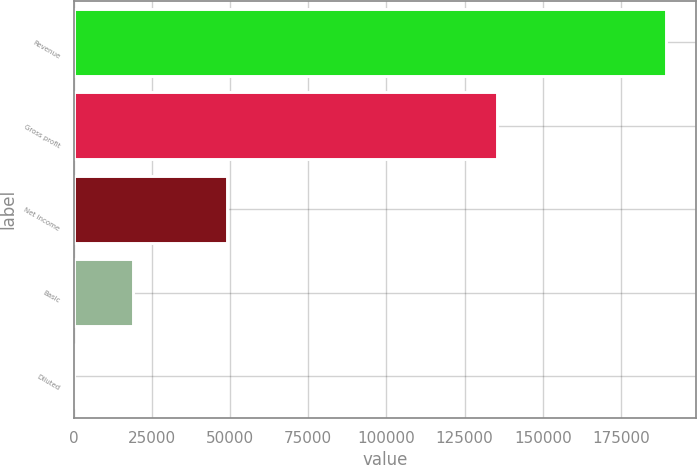Convert chart to OTSL. <chart><loc_0><loc_0><loc_500><loc_500><bar_chart><fcel>Revenue<fcel>Gross profit<fcel>Net income<fcel>Basic<fcel>Diluted<nl><fcel>189446<fcel>135200<fcel>49154<fcel>18945.7<fcel>1.24<nl></chart> 